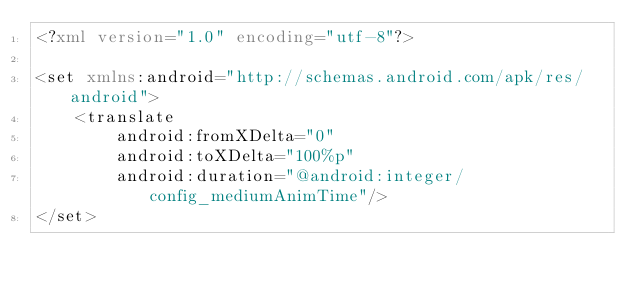Convert code to text. <code><loc_0><loc_0><loc_500><loc_500><_XML_><?xml version="1.0" encoding="utf-8"?>

<set xmlns:android="http://schemas.android.com/apk/res/android">
    <translate
        android:fromXDelta="0"
        android:toXDelta="100%p"
        android:duration="@android:integer/config_mediumAnimTime"/>
</set></code> 